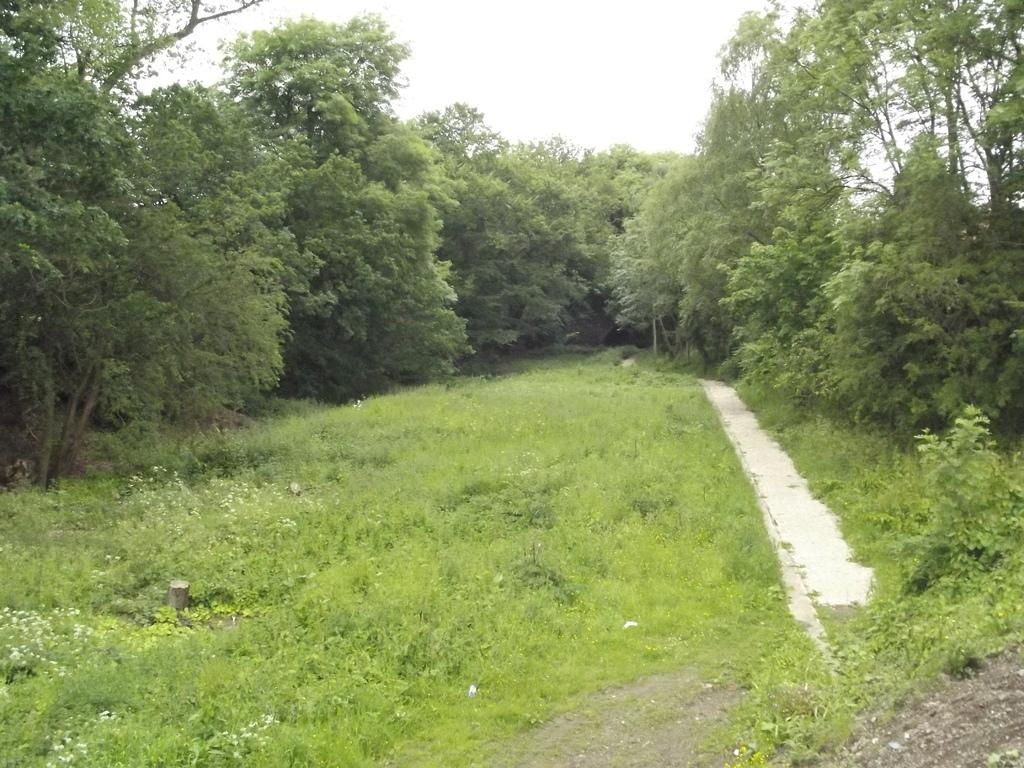What type of vegetation can be seen in the image? There is grass, plants, and trees in the image. What part of the natural environment is visible in the image? The sky is visible in the background of the image. What type of nut is being used as a hobby in the image? There is no nut or hobby present in the image; it features grass, plants, trees, and the sky. 